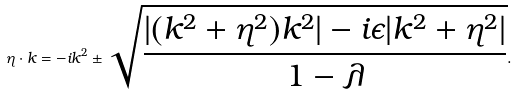Convert formula to latex. <formula><loc_0><loc_0><loc_500><loc_500>\eta \cdot k = - i k ^ { 2 } \pm \sqrt { \frac { | ( k ^ { 2 } + \eta ^ { 2 } ) k ^ { 2 } | - i \epsilon | k ^ { 2 } + \eta ^ { 2 } | } { 1 - \lambda } } .</formula> 